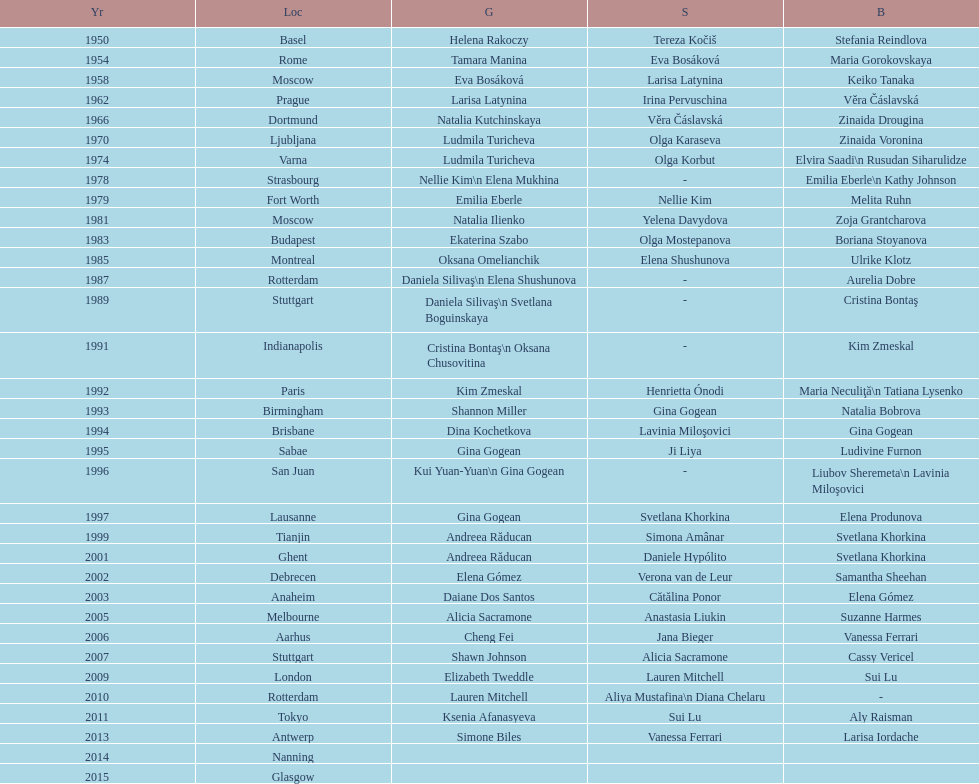What is the number of times a brazilian has won a medal? 2. 